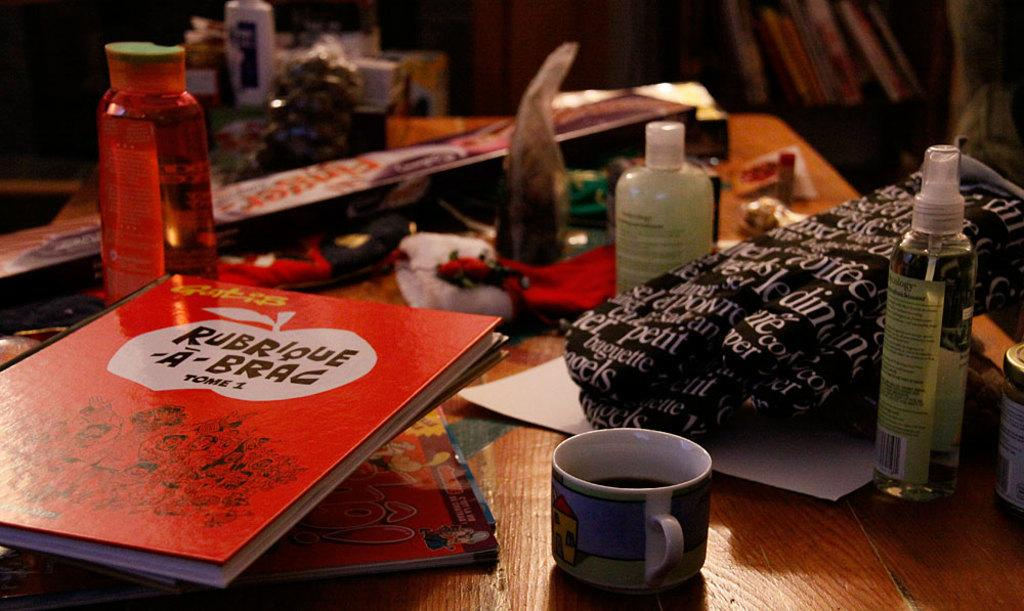<image>
Present a compact description of the photo's key features. A table covered by many different items including the book Rubrique-à-Brac Tome 1. 